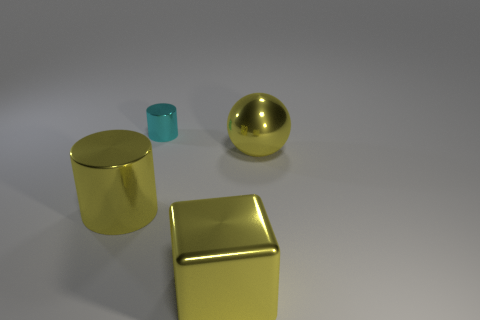There is a metallic cylinder right of the yellow metal cylinder; what size is it?
Give a very brief answer. Small. There is a large object that is to the left of the yellow metallic cube; is its color the same as the cube in front of the small metal object?
Give a very brief answer. Yes. The object that is behind the large yellow object that is behind the yellow object left of the tiny cyan metallic cylinder is made of what material?
Your answer should be compact. Metal. Are there any yellow spheres of the same size as the yellow block?
Offer a very short reply. Yes. What material is the yellow cylinder that is the same size as the yellow shiny ball?
Your answer should be very brief. Metal. There is a metallic object behind the large sphere; what is its shape?
Make the answer very short. Cylinder. Is the large yellow thing that is to the left of the cyan shiny object made of the same material as the large object right of the yellow metal block?
Offer a terse response. Yes. What number of other metallic objects have the same shape as the tiny object?
Provide a short and direct response. 1. What material is the big ball that is the same color as the big cylinder?
Ensure brevity in your answer.  Metal. How many objects are big blue shiny blocks or big yellow metallic things in front of the big yellow metal sphere?
Your response must be concise. 2. 